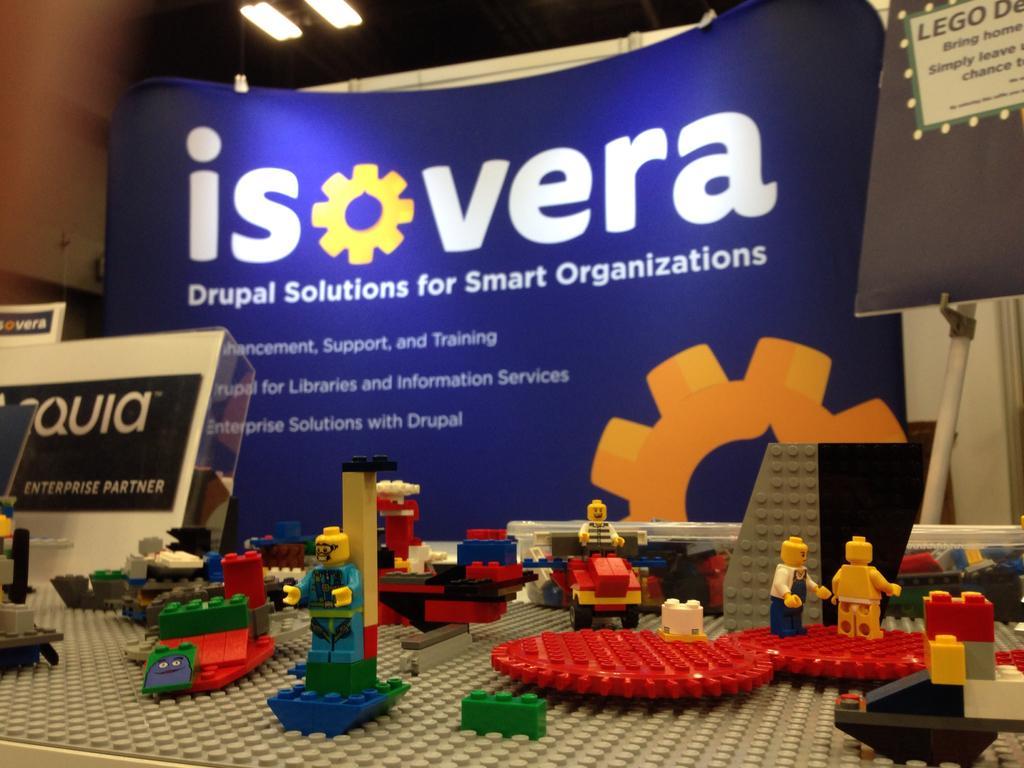In one or two sentences, can you explain what this image depicts? In this picture we can see some toys here, in the background there is a hoarding, on the right side we can see a board, we can see lights at the top of the picture. 